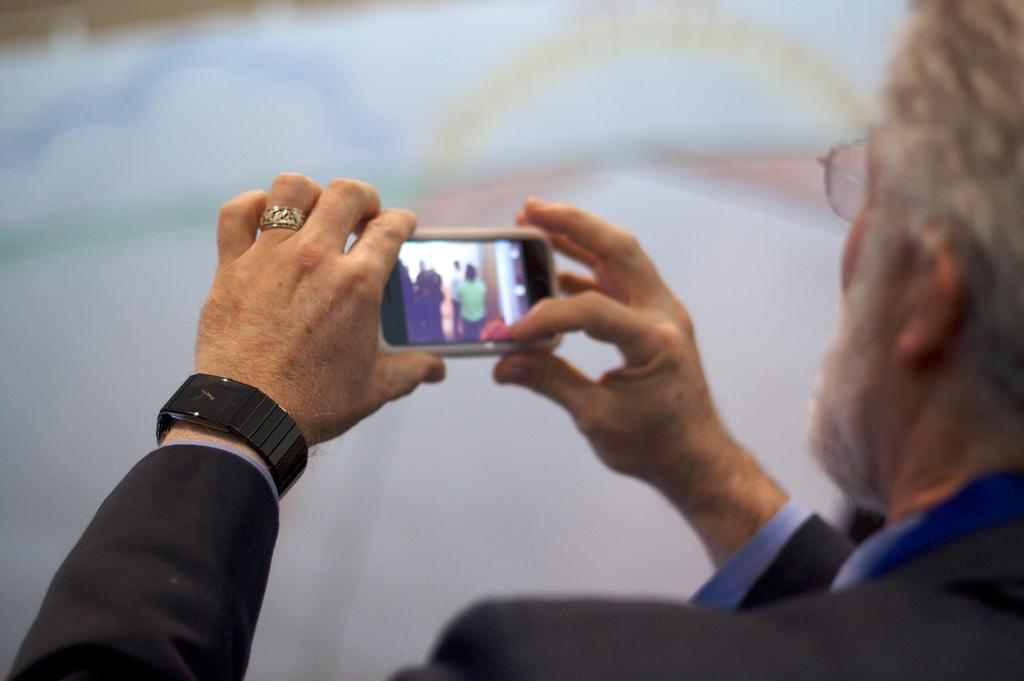What is the person in the image doing? The person in the image is taking a photo. What object is the person holding while taking the photo? The person is holding a phone while taking the photo. What type of wound can be seen on the person's hand in the image? There is no wound visible on the person's hand in the image. Are there any bears present in the image? No, there are no bears present in the image. 